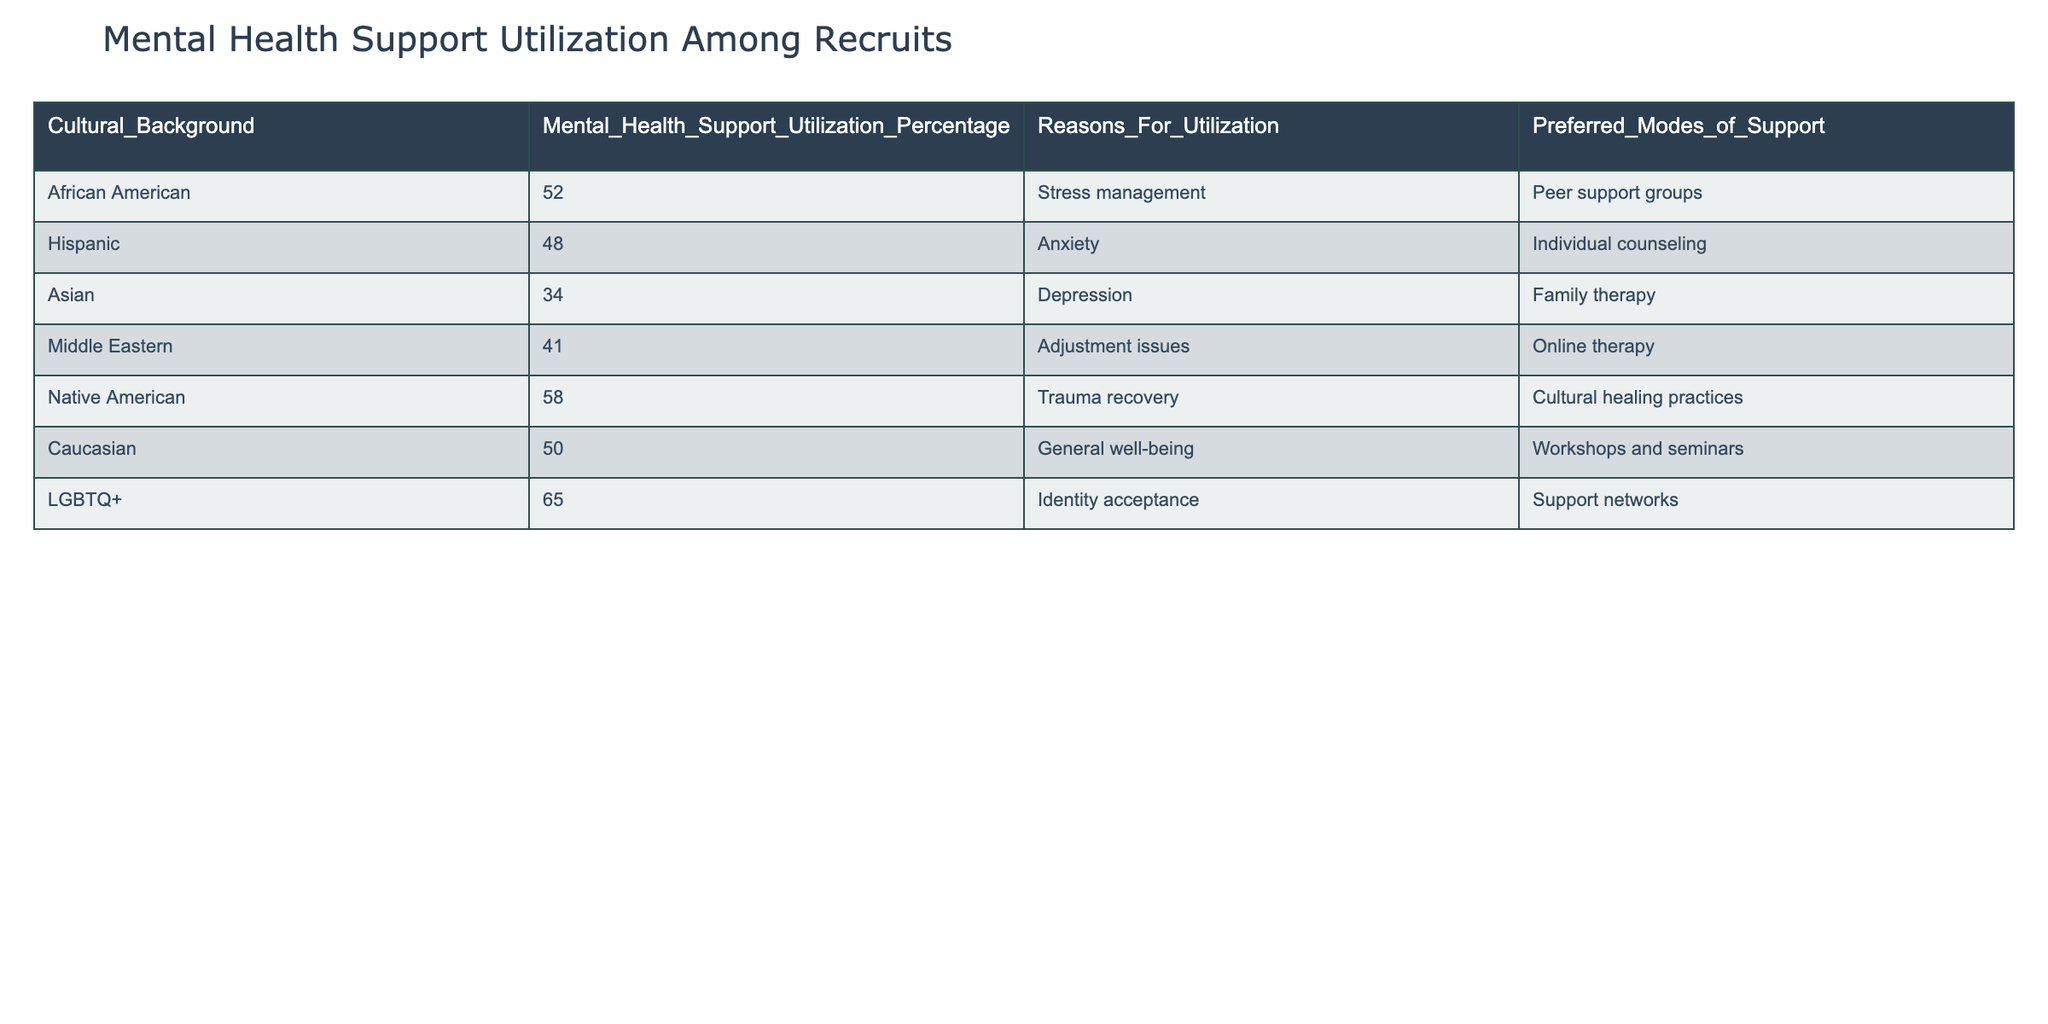What is the mental health support utilization percentage for Native American recruits? According to the table, the specific figure for Native American recruits is readily available in the "Mental Health Support Utilization Percentage" column, which indicates a utilization percentage of 58.
Answer: 58 Which cultural background has the highest percentage of mental health support utilization? By examining the percentages listed in the table, the LGBTQ+ cultural background shows the highest percentage at 65, compared to other groups.
Answer: LGBTQ+ What percentage of Asian recruits utilize mental health support? The percentage for Asian recruits is explicitly listed in the "Mental Health Support Utilization Percentage" column as 34.
Answer: 34 Is it true that Caucasian recruits have a lower percentage of mental health support utilization than African American recruits? By comparing the figures in the table, Caucasian recruits have a utilization percentage of 50, while African American recruits have 52, making the statement false.
Answer: No What are the two most common preferred modes of support among recruits? Analyzing the "Preferred Modes of Support" column reveals that the most common are "Peer support groups" (for African American recruits) and "Support networks" (for LGBTQ+ recruits). This suggests that these two modes are widely preferred.
Answer: Peer support groups, Support networks What is the average mental health support utilization percentage across all cultural backgrounds? To find the average, sum the percentages (52 + 48 + 34 + 41 + 58 + 50 + 65 = 348) and divide by the number of groups (7). Thus, 348/7 = 49.71.
Answer: 49.71 What is the difference between the mental health support utilization percentage of LGBTQ+ recruits and that of Hispanic recruits? The percentage for LGBTQ+ recruits is 65, and for Hispanic recruits, it is 48. The difference is calculated as 65 - 48 = 17.
Answer: 17 Are online therapy and family therapy listed as preferred modes of support by any of the recruits, and if so, which groups prefer them? Upon reviewing the "Preferred Modes of Support," it is found that Middle Eastern recruits prefer online therapy and Asian recruits prefer family therapy.
Answer: Yes, Middle Eastern and Asian recruits 